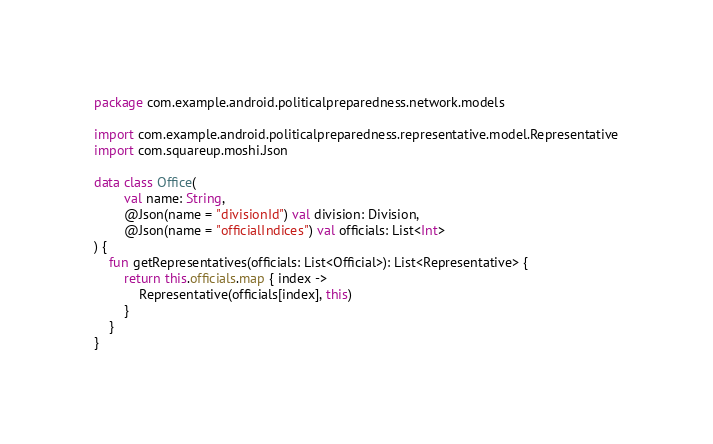<code> <loc_0><loc_0><loc_500><loc_500><_Kotlin_>package com.example.android.politicalpreparedness.network.models

import com.example.android.politicalpreparedness.representative.model.Representative
import com.squareup.moshi.Json

data class Office(
        val name: String,
        @Json(name = "divisionId") val division: Division,
        @Json(name = "officialIndices") val officials: List<Int>
) {
    fun getRepresentatives(officials: List<Official>): List<Representative> {
        return this.officials.map { index ->
            Representative(officials[index], this)
        }
    }
}
</code> 